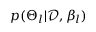<formula> <loc_0><loc_0><loc_500><loc_500>p ( \Theta _ { l } | \mathcal { D } , \beta _ { l } )</formula> 